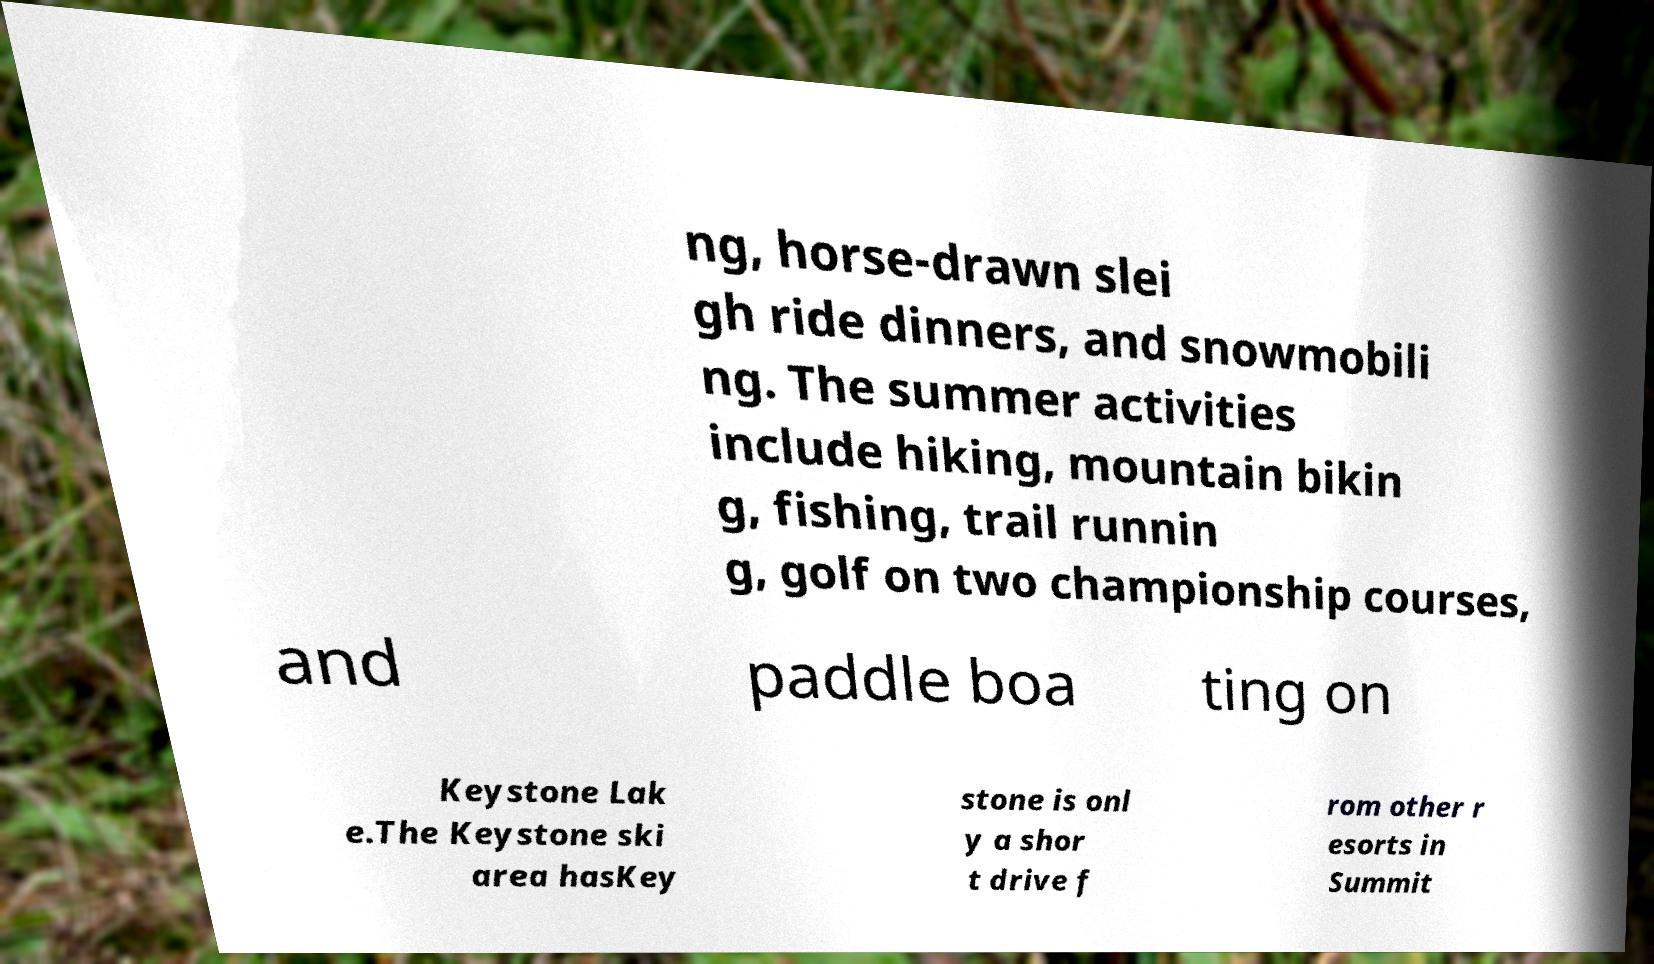Please read and relay the text visible in this image. What does it say? ng, horse-drawn slei gh ride dinners, and snowmobili ng. The summer activities include hiking, mountain bikin g, fishing, trail runnin g, golf on two championship courses, and paddle boa ting on Keystone Lak e.The Keystone ski area hasKey stone is onl y a shor t drive f rom other r esorts in Summit 